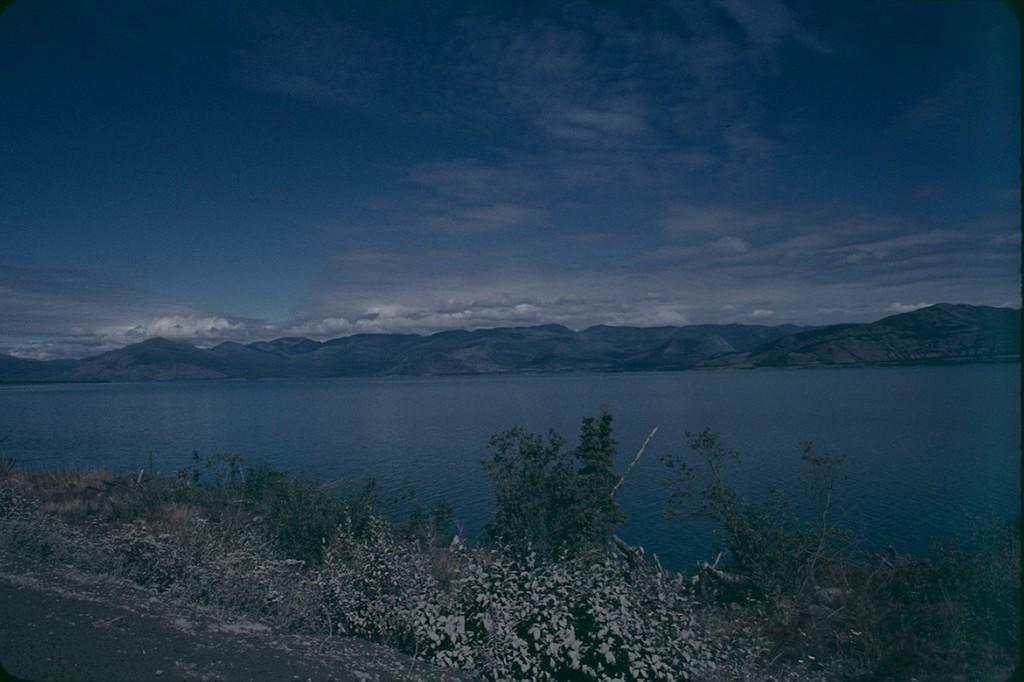How would you summarize this image in a sentence or two? In the image there is a clear sky and over here there is a river either sides of the river there are plants and mountains. Beside plants there is a road. 